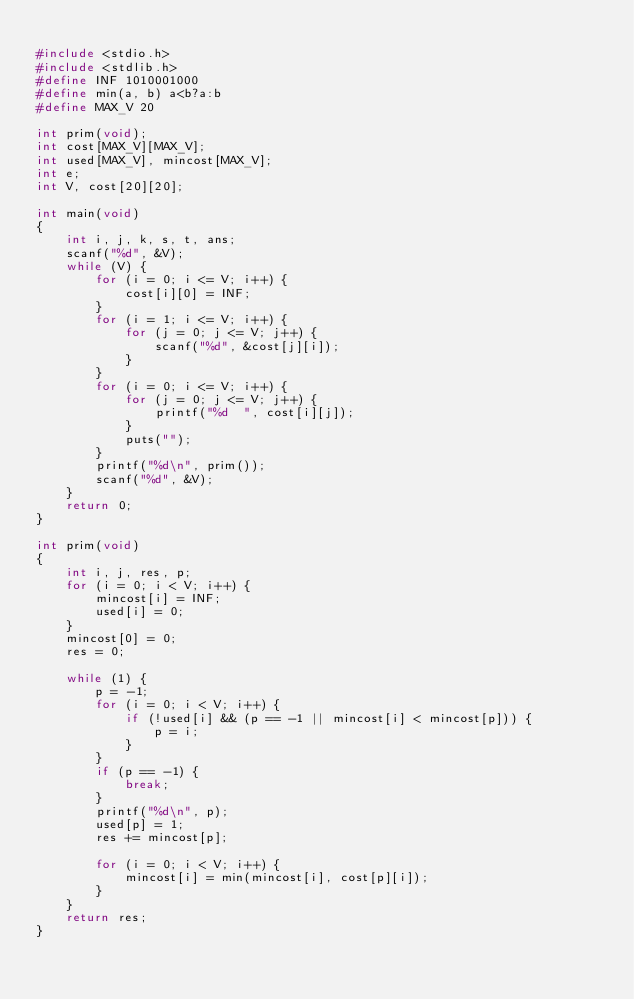<code> <loc_0><loc_0><loc_500><loc_500><_C_>
#include <stdio.h>
#include <stdlib.h>
#define INF 1010001000
#define min(a, b) a<b?a:b
#define MAX_V 20

int prim(void);
int cost[MAX_V][MAX_V];
int used[MAX_V], mincost[MAX_V];
int e;
int V, cost[20][20];

int main(void)
{
    int i, j, k, s, t, ans;
    scanf("%d", &V);
    while (V) {
        for (i = 0; i <= V; i++) {
            cost[i][0] = INF;
        }
        for (i = 1; i <= V; i++) {
            for (j = 0; j <= V; j++) {
                scanf("%d", &cost[j][i]);
            }
        }
        for (i = 0; i <= V; i++) { 
            for (j = 0; j <= V; j++) {
                printf("%d  ", cost[i][j]);
            }
            puts("");
        }
        printf("%d\n", prim());
        scanf("%d", &V);
    }
    return 0;
}

int prim(void)
{
    int i, j, res, p;
    for (i = 0; i < V; i++) {
        mincost[i] = INF;
        used[i] = 0;
    }
    mincost[0] = 0;
    res = 0;

    while (1) {
        p = -1;
        for (i = 0; i < V; i++) {
            if (!used[i] && (p == -1 || mincost[i] < mincost[p])) {
                p = i;
            }
        }
        if (p == -1) {
            break;
        }
        printf("%d\n", p);
        used[p] = 1;
        res += mincost[p];

        for (i = 0; i < V; i++) {
            mincost[i] = min(mincost[i], cost[p][i]);
        }
    }
    return res;
}</code> 